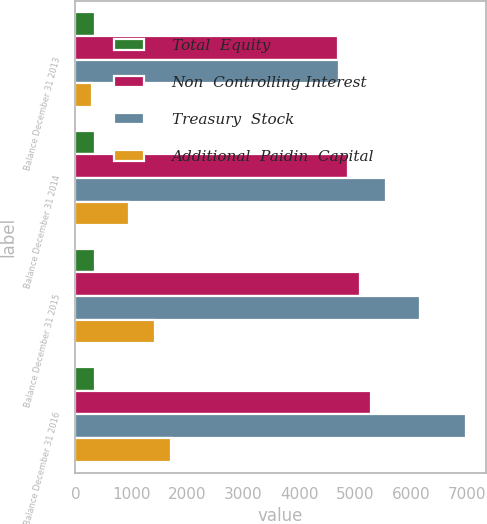Convert chart to OTSL. <chart><loc_0><loc_0><loc_500><loc_500><stacked_bar_chart><ecel><fcel>Balance December 31 2013<fcel>Balance December 31 2014<fcel>Balance December 31 2015<fcel>Balance December 31 2016<nl><fcel>Total  Equity<fcel>345.1<fcel>347.7<fcel>350.3<fcel>352.6<nl><fcel>Non  Controlling Interest<fcel>4692<fcel>4874.5<fcel>5086.1<fcel>5270.8<nl><fcel>Treasury  Stock<fcel>4699<fcel>5555.1<fcel>6160.3<fcel>6975<nl><fcel>Additional  Paidin  Capital<fcel>305.2<fcel>951.9<fcel>1423.3<fcel>1712.9<nl></chart> 